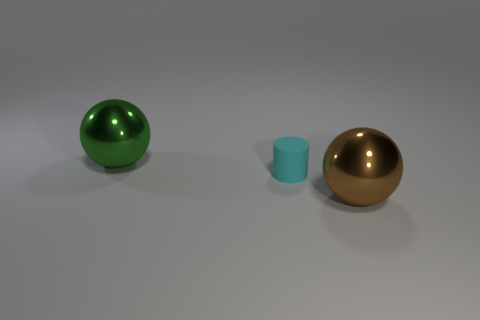Add 1 large spheres. How many objects exist? 4 Subtract all cylinders. How many objects are left? 2 Add 3 brown objects. How many brown objects are left? 4 Add 1 tiny blocks. How many tiny blocks exist? 1 Subtract 0 gray balls. How many objects are left? 3 Subtract all rubber objects. Subtract all tiny cyan cubes. How many objects are left? 2 